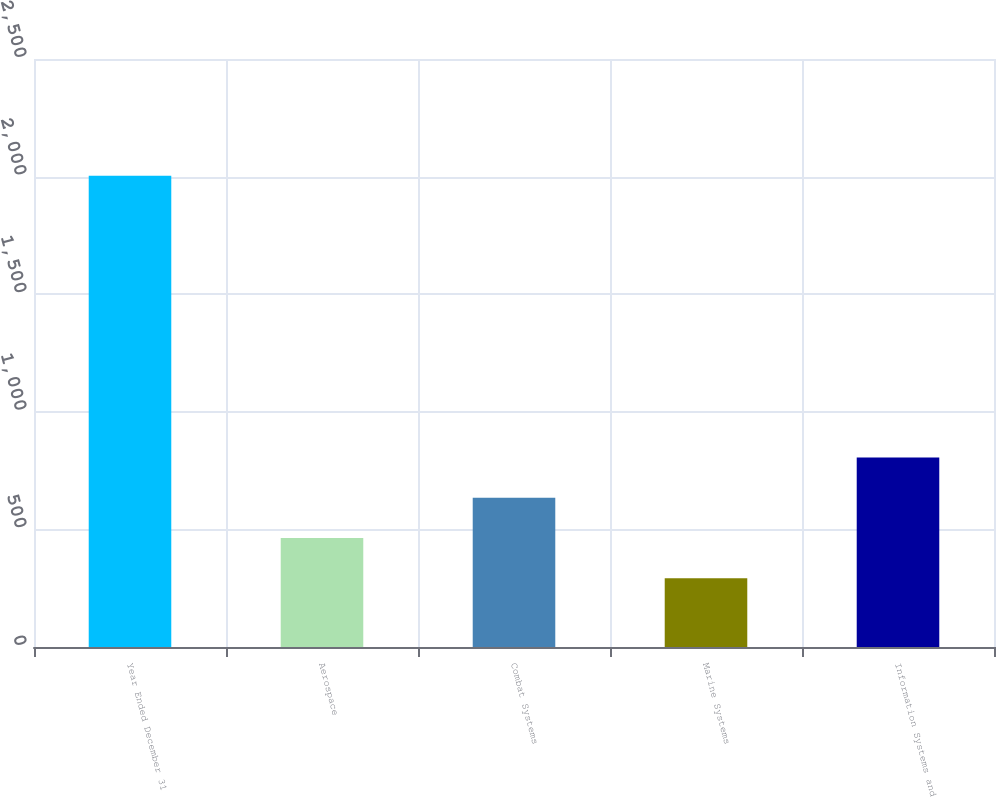Convert chart to OTSL. <chart><loc_0><loc_0><loc_500><loc_500><bar_chart><fcel>Year Ended December 31<fcel>Aerospace<fcel>Combat Systems<fcel>Marine Systems<fcel>Information Systems and<nl><fcel>2004<fcel>463.2<fcel>634.4<fcel>292<fcel>805.6<nl></chart> 